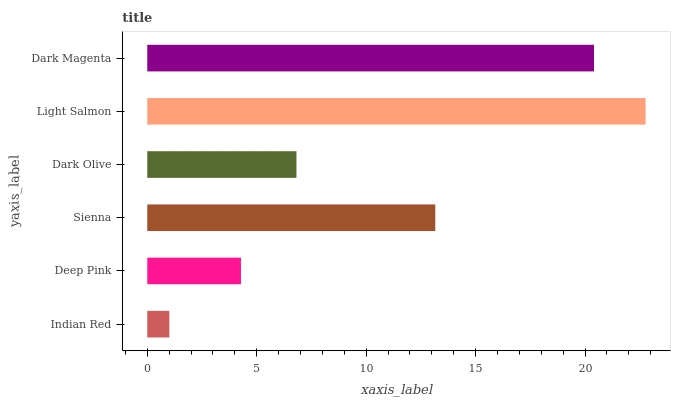Is Indian Red the minimum?
Answer yes or no. Yes. Is Light Salmon the maximum?
Answer yes or no. Yes. Is Deep Pink the minimum?
Answer yes or no. No. Is Deep Pink the maximum?
Answer yes or no. No. Is Deep Pink greater than Indian Red?
Answer yes or no. Yes. Is Indian Red less than Deep Pink?
Answer yes or no. Yes. Is Indian Red greater than Deep Pink?
Answer yes or no. No. Is Deep Pink less than Indian Red?
Answer yes or no. No. Is Sienna the high median?
Answer yes or no. Yes. Is Dark Olive the low median?
Answer yes or no. Yes. Is Light Salmon the high median?
Answer yes or no. No. Is Sienna the low median?
Answer yes or no. No. 